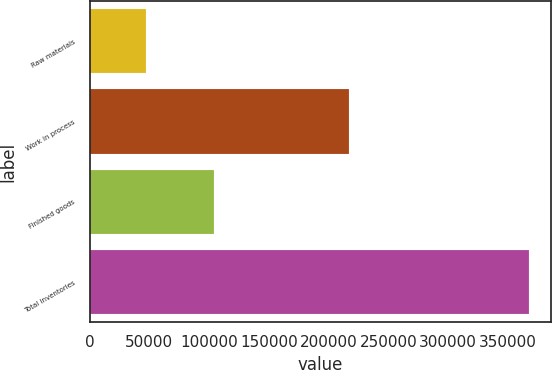<chart> <loc_0><loc_0><loc_500><loc_500><bar_chart><fcel>Raw materials<fcel>Work in process<fcel>Finished goods<fcel>Total inventories<nl><fcel>47267<fcel>216765<fcel>103895<fcel>367927<nl></chart> 